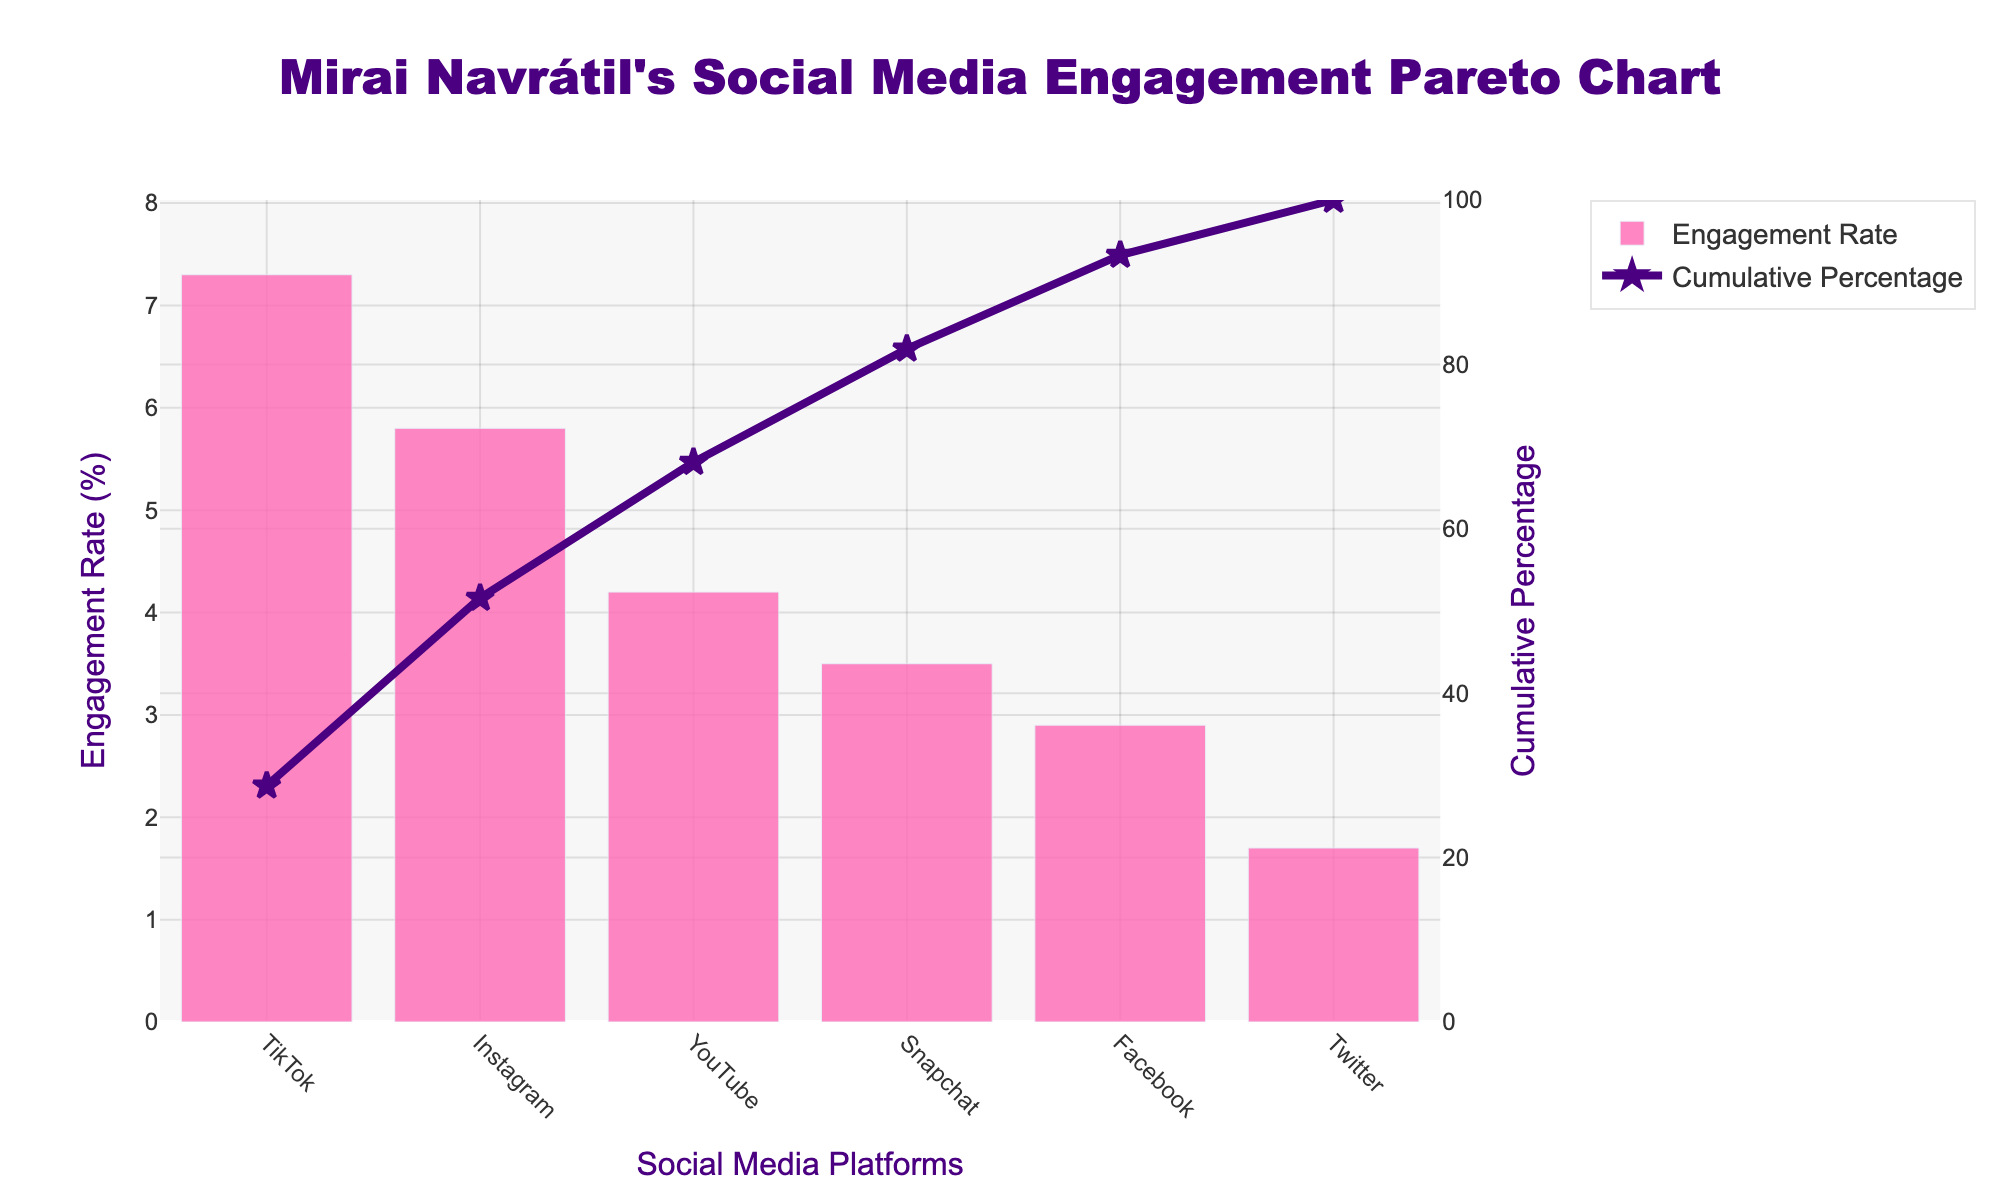What's the highest engagement rate platform for Mirai Navrátil? The highest engagement rate is the tallest bar on the chart. TikTok has the tallest bar.
Answer: TikTok What is the title of the chart? The title is displayed prominently at the top of the chart.
Answer: Mirai Navrátil's Social Media Engagement Pareto Chart What is the engagement rate for Snapchat? Find the Snapchat bar on the x-axis and check the height corresponding to the y-axis.
Answer: 3.5% Which platform has the lowest engagement rate? The shortest bar on the chart represents the lowest engagement rate.
Answer: Twitter What percentage of the cumulative engagement does Instagram contribute? Trace the Instagram bar to the cumulative percentage line and read the value on the right y-axis.
Answer: 30% What’s the cumulative percentage after three platforms? Add the engagement rates of TikTok, Instagram, and YouTube, then calculate their cumulative percentage. (7.3 + 5.8 + 4.2) = 17.3, then 17.3 / (7.3 + 5.8 + 4.2 + 2.9 + 1.7 + 3.5) = 17.3 / 25.4 ≈ 68.1%.
Answer: 68.1% How does the engagement rate of Facebook compare to YouTube? Observe the heights of the bars for Facebook and YouTube. YouTube's bar is higher than Facebook's.
Answer: Less than YouTube How many platforms have an engagement rate higher than 4%? Count the bars that have a height greater than 4% on the y-axis. TikTok, Instagram, and YouTube exceed 4%.
Answer: 3 Is the cumulative percentage for Twitter higher than for Snapchat? Compare the cumulative percentages on the right y-axis for Twitter and Snapchat. Snapchat's cumulative percentage is higher.
Answer: No Which platform lies at the 80% cumulative percentage mark? Follow the cumulative percentage line to 80% on the right y-axis, then trace directly down to the x-axis. Facebook achieves this with TikTok, Instagram, YouTube, and Snapchat preceding it.
Answer: Facebook 